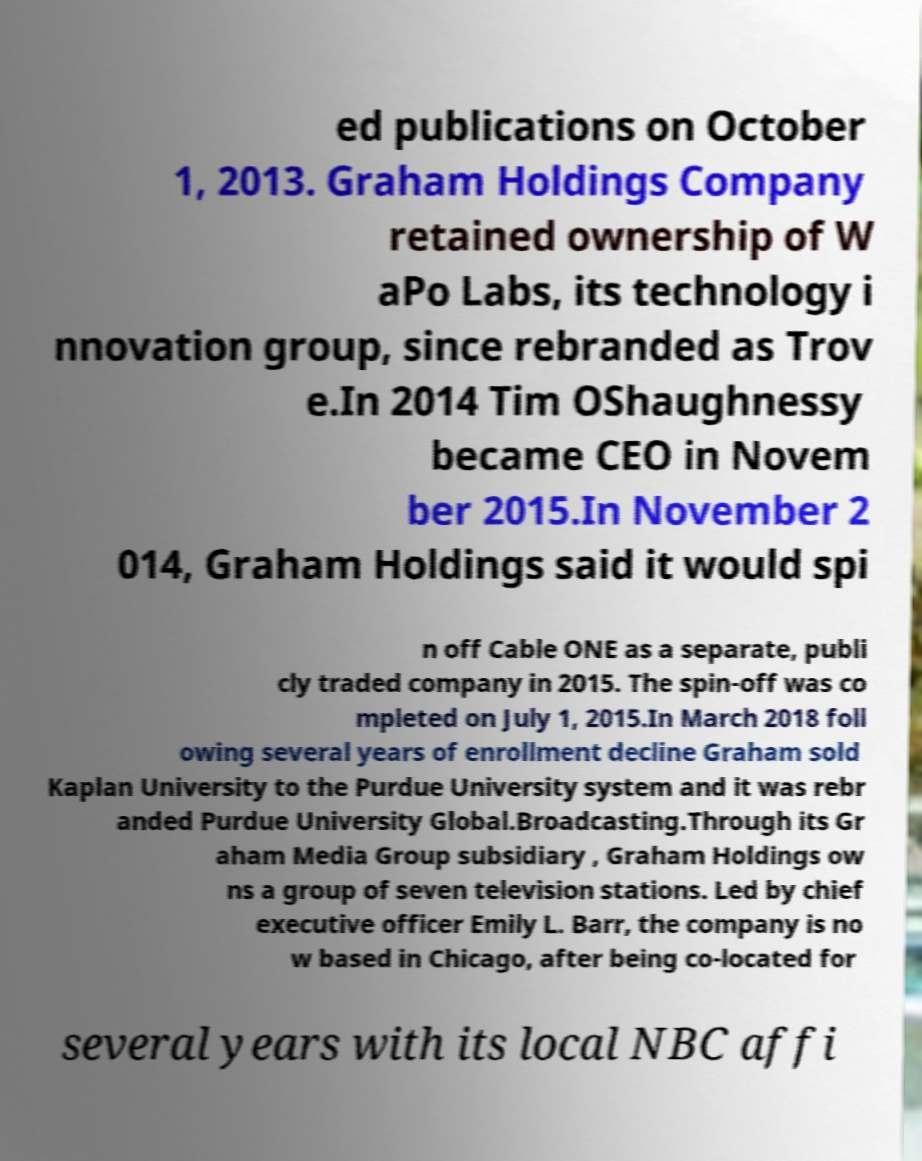Could you assist in decoding the text presented in this image and type it out clearly? ed publications on October 1, 2013. Graham Holdings Company retained ownership of W aPo Labs, its technology i nnovation group, since rebranded as Trov e.In 2014 Tim OShaughnessy became CEO in Novem ber 2015.In November 2 014, Graham Holdings said it would spi n off Cable ONE as a separate, publi cly traded company in 2015. The spin-off was co mpleted on July 1, 2015.In March 2018 foll owing several years of enrollment decline Graham sold Kaplan University to the Purdue University system and it was rebr anded Purdue University Global.Broadcasting.Through its Gr aham Media Group subsidiary , Graham Holdings ow ns a group of seven television stations. Led by chief executive officer Emily L. Barr, the company is no w based in Chicago, after being co-located for several years with its local NBC affi 